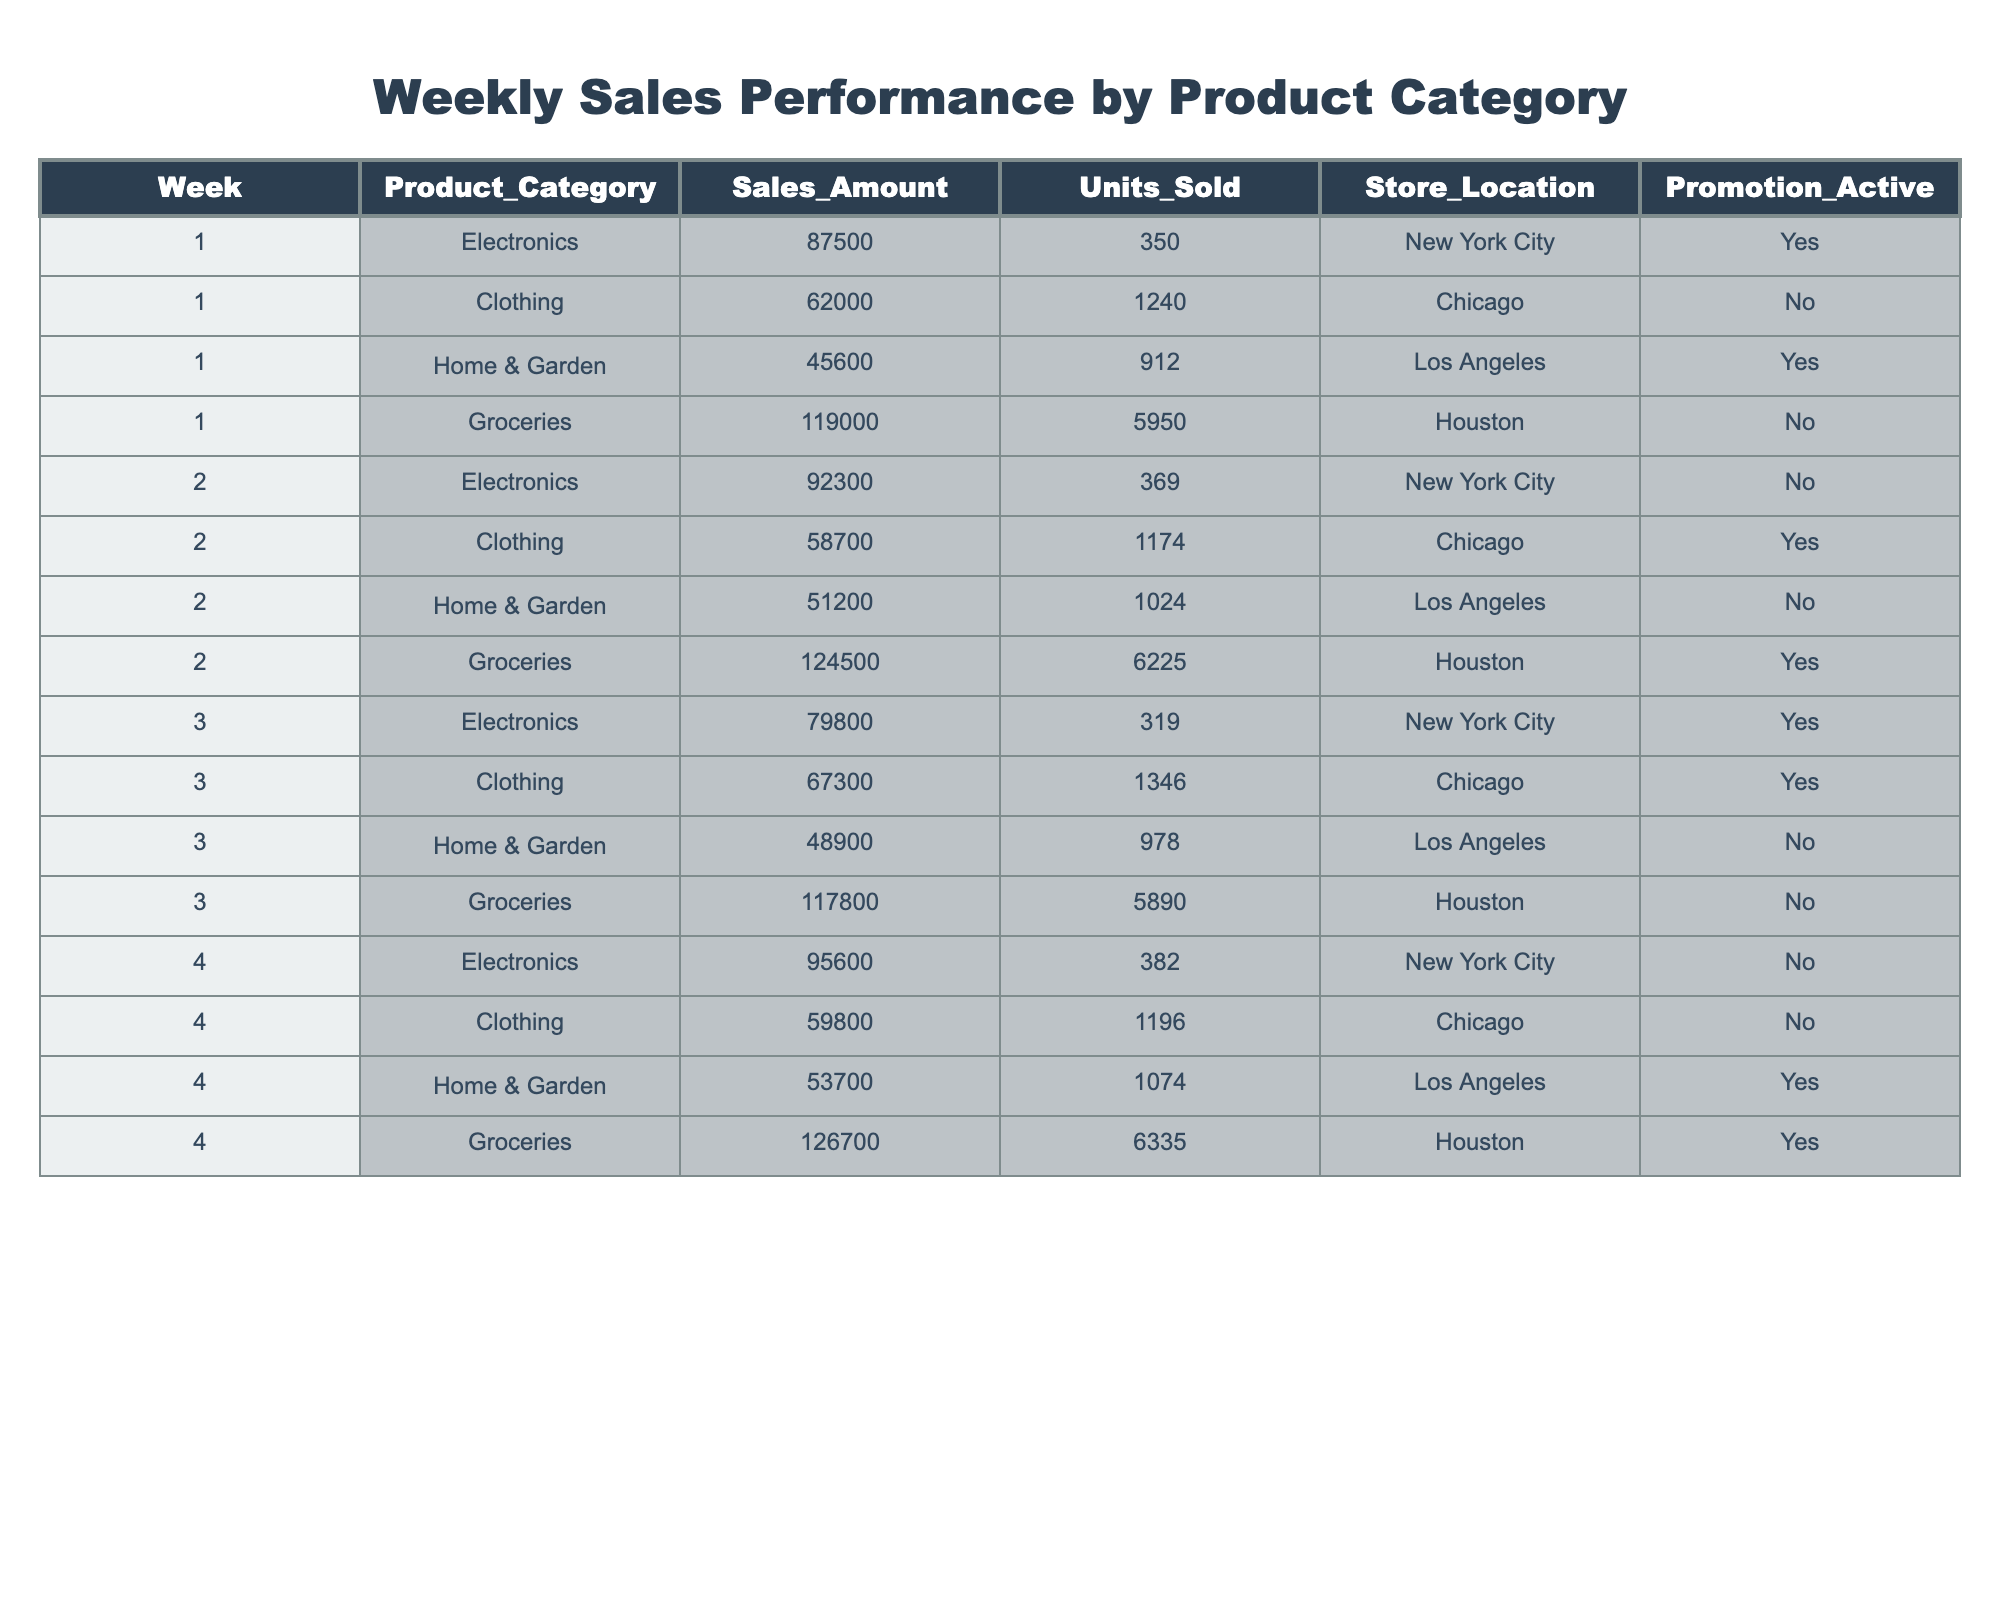What was the highest sales amount in week 1? In week 1, the sales amounts for each category were Electronics (87500), Clothing (62000), Home & Garden (45600), and Groceries (119000). The highest sales amount is 119000 from Groceries.
Answer: 119000 Which product category had the most units sold in week 2? In week 2, the units sold were Electronics (369), Clothing (1174), Home & Garden (1024), and Groceries (6225). Groceries had the most units sold at 6225.
Answer: Groceries What was the total sales amount for Clothing across all four weeks? The sales amounts for Clothing in the four weeks are 62000, 58700, 67300, and 59800. Summing these gives 62000 + 58700 + 67300 + 59800 = 247800.
Answer: 247800 Was there a promotion active for Electronics in week 3? In week 3, the promotion status for Electronics is indicated as Yes. Therefore, there was a promotion active for that category.
Answer: Yes What product category had the highest sales in any single week, and what was the amount? We check the highest sales amounts from each week: Week 1 (Groceries 119000), Week 2 (Groceries 124500), Week 3 (Groceries 117800), Week 4 (Groceries 126700). The highest sales is 126700 in week 4 for Groceries.
Answer: Groceries, 126700 Calculate the average units sold for Home & Garden over the four weeks. The units sold for Home & Garden are 912, 1024, 978, and 1074. First, we sum these values: 912 + 1024 + 978 + 1074 = 3988. Then we divide by 4 (because there are four weeks): 3988 / 4 = 997.
Answer: 997 Did Clothing have higher sales in week 2 than in week 1? In week 1, Clothing sales were 62000 and in week 2 it was 58700. Since 62000 is greater than 58700, Clothing had higher sales in week 1.
Answer: No What is the total sales amount for all products combined in week 4? The sales amounts for week 4 are Electronics (95600), Clothing (59800), Home & Garden (53700), and Groceries (126700). Adding these amounts together gives 95600 + 59800 + 53700 + 126700 = 336800.
Answer: 336800 Was there a week where all product categories had promotions active? By checking the promotion status for each week: Week 1 (Yes, No, Yes, No), Week 2 (No, Yes, No, Yes), Week 3 (Yes, Yes, No, No), Week 4 (No, No, Yes, Yes), there is no week where all categories had promotions active.
Answer: No Identify the week with the lowest total units sold across all product categories. For each week, the total units sold are: Week 1: 350 + 1240 + 912 + 5950 = 7152; Week 2: 369 + 1174 + 1024 + 6225 = 6792; Week 3: 319 + 1346 + 978 + 5890 = 6533; Week 4: 382 + 1196 + 1074 + 6335 = 7987. The lowest total units sold was 6533 in week 3.
Answer: Week 3 